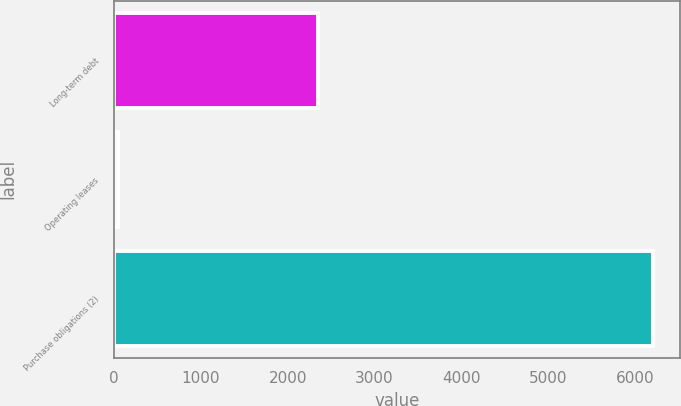Convert chart. <chart><loc_0><loc_0><loc_500><loc_500><bar_chart><fcel>Long-term debt<fcel>Operating leases<fcel>Purchase obligations (2)<nl><fcel>2349<fcel>41<fcel>6205<nl></chart> 